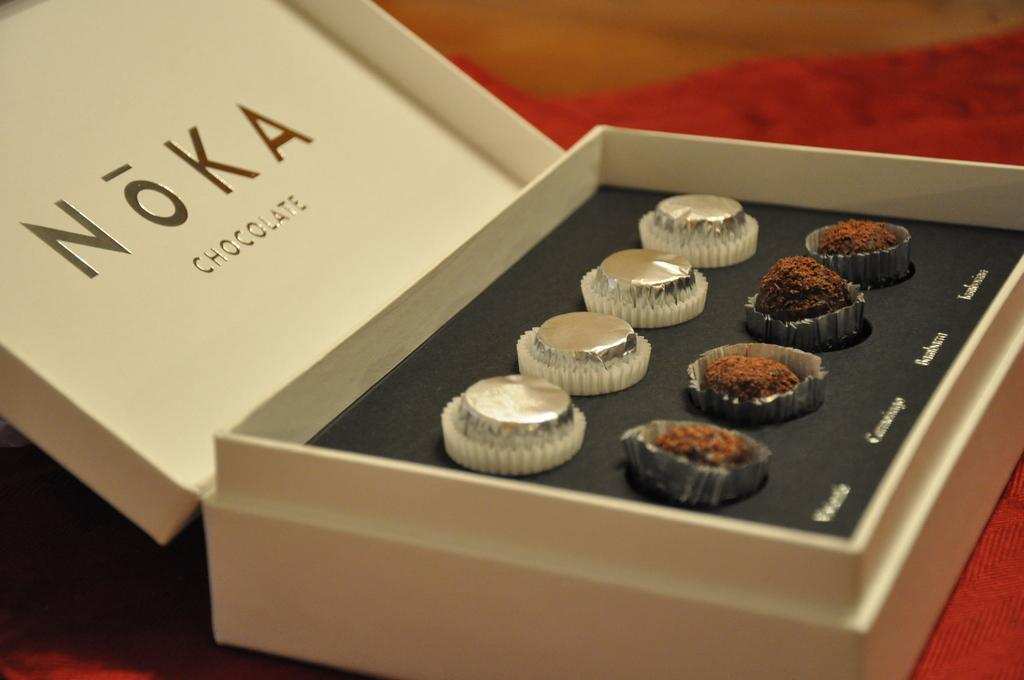What is the main object in the image? There is a chocolate box in the image. What is inside the chocolate box? The chocolate box contains chocolates. What color or pattern can be seen on an item in the image? There is a red cloth in the image. How would you describe the background of the image? The background of the image appears blurry. What type of cactus is present in the image? There is no cactus present in the image. 